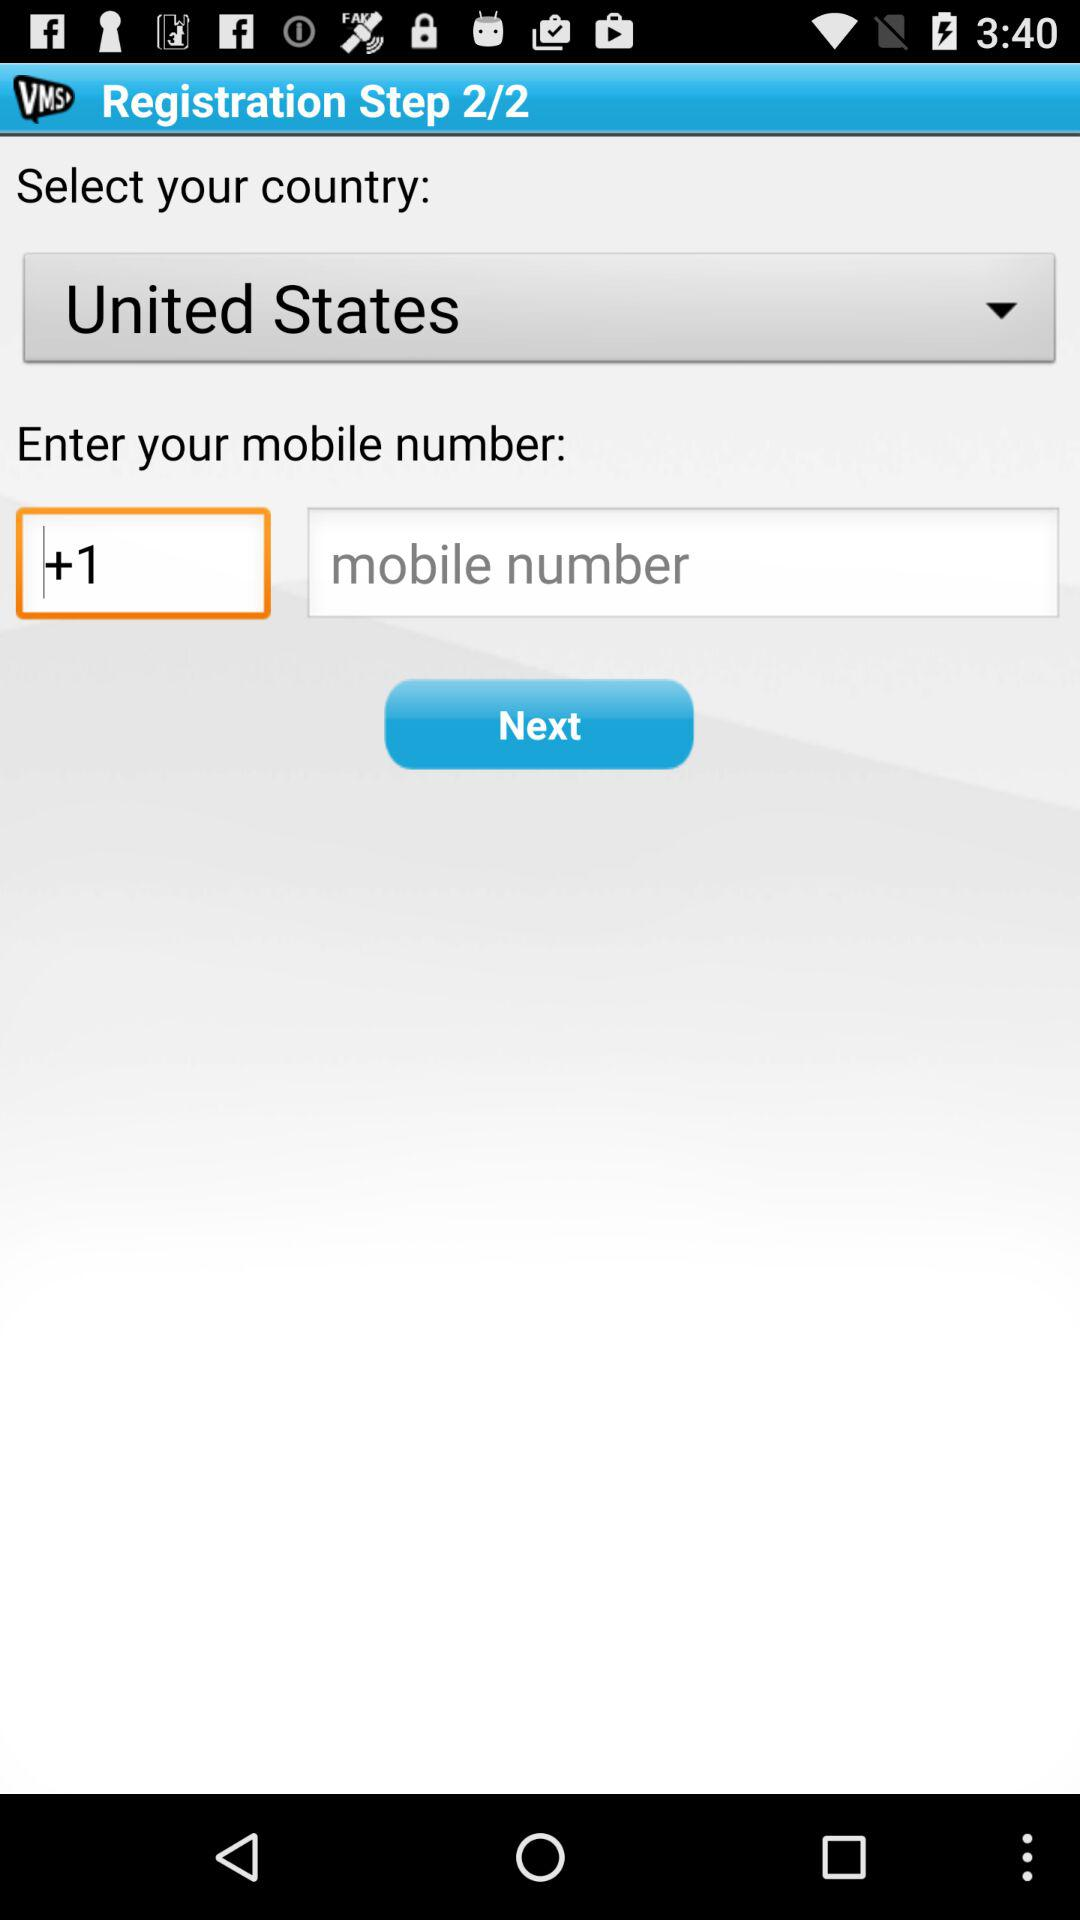What is the entered mobile code? The entered mobile code is +1. 